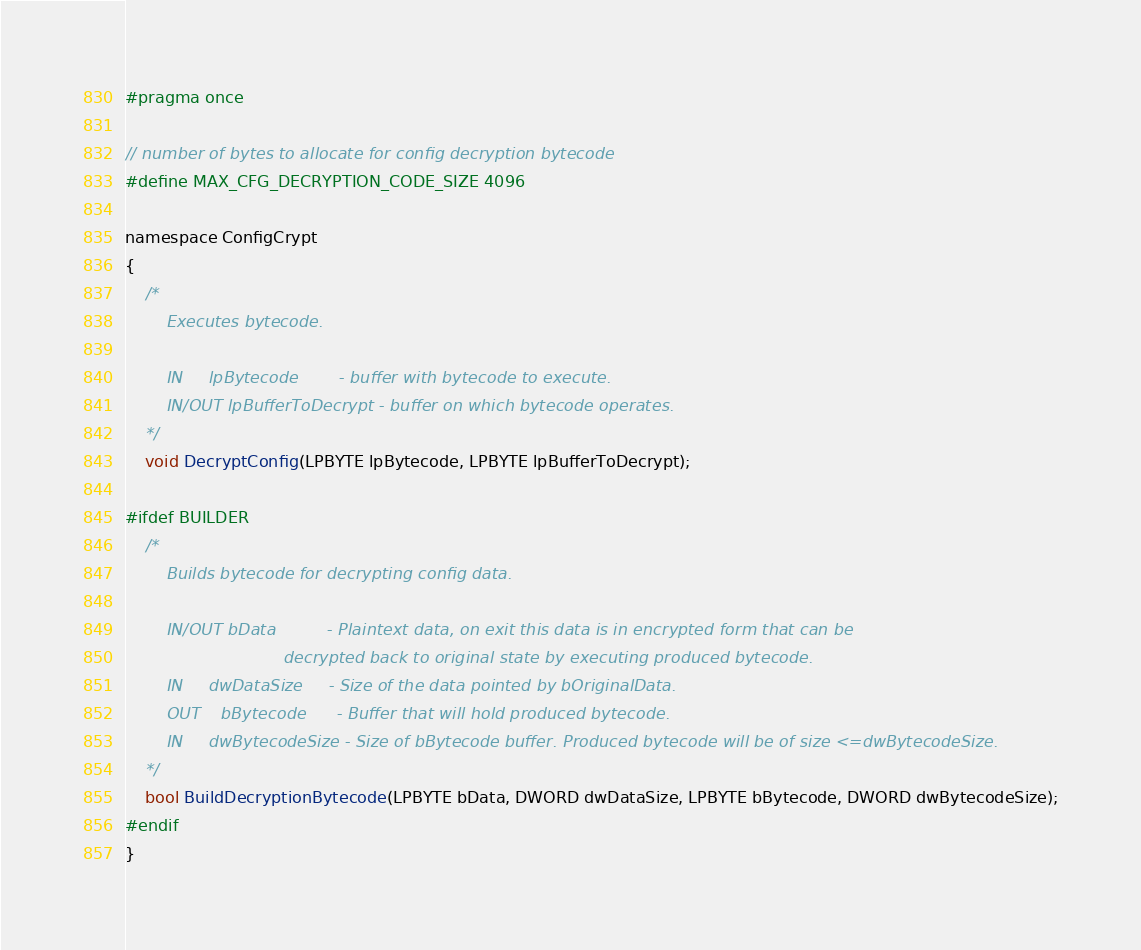Convert code to text. <code><loc_0><loc_0><loc_500><loc_500><_C_>#pragma once

// number of bytes to allocate for config decryption bytecode
#define MAX_CFG_DECRYPTION_CODE_SIZE 4096

namespace ConfigCrypt
{
	/*
		Executes bytecode.

		IN	   lpBytecode		 - buffer with bytecode to execute.
		IN/OUT lpBufferToDecrypt - buffer on which bytecode operates.
	*/
	void DecryptConfig(LPBYTE lpBytecode, LPBYTE lpBufferToDecrypt);

#ifdef BUILDER
	/*
		Builds bytecode for decrypting config data.

		IN/OUT bData          - Plaintext data, on exit this data is in encrypted form that can be
							   decrypted back to original state by executing produced bytecode.
		IN     dwDataSize     - Size of the data pointed by bOriginalData.
		OUT    bBytecode	  - Buffer that will hold produced bytecode.
		IN     dwBytecodeSize - Size of bBytecode buffer. Produced bytecode will be of size <=dwBytecodeSize.
	*/
	bool BuildDecryptionBytecode(LPBYTE bData, DWORD dwDataSize, LPBYTE bBytecode, DWORD dwBytecodeSize);
#endif
}

</code> 